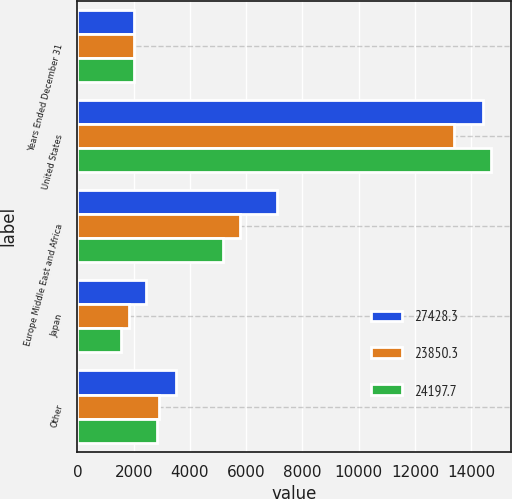Convert chart to OTSL. <chart><loc_0><loc_0><loc_500><loc_500><stacked_bar_chart><ecel><fcel>Years Ended December 31<fcel>United States<fcel>Europe Middle East and Africa<fcel>Japan<fcel>Other<nl><fcel>27428.3<fcel>2009<fcel>14401.2<fcel>7093.1<fcel>2425.6<fcel>3508.4<nl><fcel>23850.3<fcel>2008<fcel>13370.5<fcel>5773.8<fcel>1823.5<fcel>2882.5<nl><fcel>24197.7<fcel>2007<fcel>14690.9<fcel>5159<fcel>1533.2<fcel>2814.6<nl></chart> 